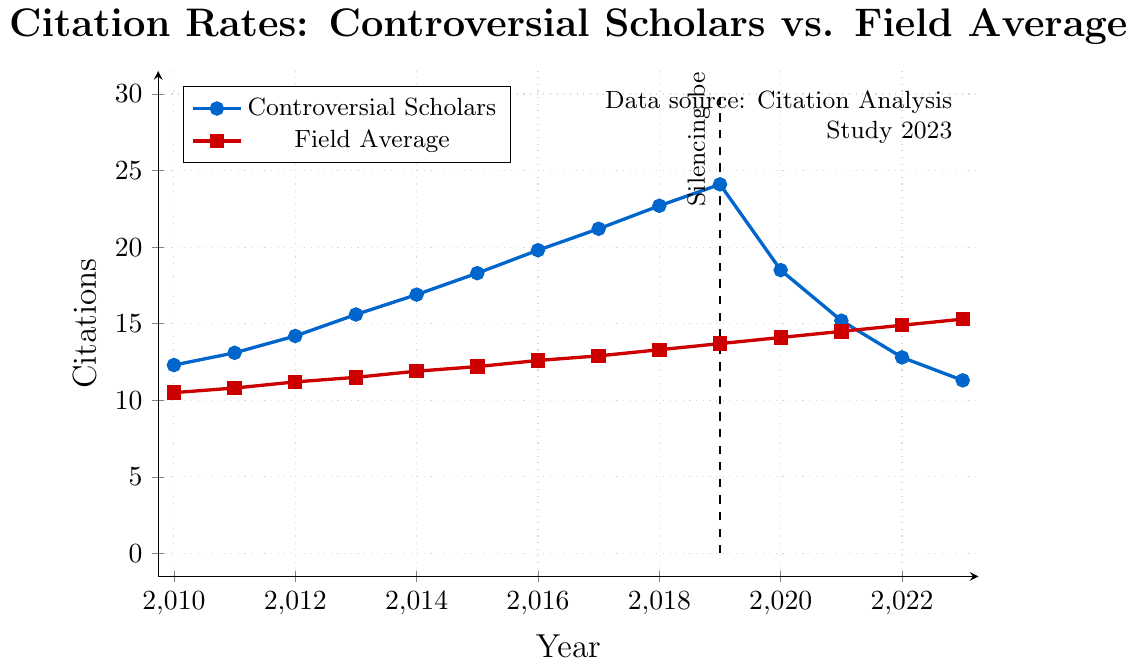what trend do you observe in the citation rates of controversial scholars after 2019 compared to the field average? After 2019, the citation rates for controversial scholars show a clear downward trend, from 24.1 to 11.3 in 2023. However, the field average continues to rise steadily from 13.7 to 15.3 during the same period. Thus, the citation rates for controversial scholars fall below the field average post-2019.
Answer: Downward for controversial scholars, upward for field average What was the highest citation rate for controversial scholars before they were silenced? To identify the highest citation rate for controversial scholars before they were silenced, examine the trend up to 2019. The rates are: 12.3, 13.1, 14.2, 15.6, 16.9, 18.3, 19.8, 21.2, 22.7, 24.1. The highest value among these is 24.1 in 2019.
Answer: 24.1 Compare the citation rates of controversial scholars and the field average in 2023. In 2023, the citation rate for controversial scholars is 11.3, while the field average is 15.3. The citation rate for controversial scholars is lower than the field average by (15.3 - 11.3) = 4.0.
Answer: Controversial scholars: 11.3, Field average: 15.3 How much did the citation rate of controversial scholars change from 2019 to 2023? The citation rate for controversial scholars in 2019 was 24.1 and in 2023 it is 11.3. The change is calculated as 24.1 - 11.3 = 12.8. Thus, there was a decrease of 12.8 citations.
Answer: Decreased by 12.8 What year did controversial scholars' citation rates start declining, and how does this compare to the trend in the field average? The citation rates for controversial scholars start to decline after 2019, when the silencing begins, while the field average continues its upward trend. By comparing the values visually, the decline starts in 2020, and the difference widens in the subsequent years.
Answer: Decline starts in 2020 for controversial scholars, field average continues to increase What is the visual indication of the start of the silencing period in the plot? The plot has a dashed vertical line labelled "Silencing begins" at the year 2019, which visually indicates the start of the silencing period. This line helps to identify the point of change in the citation trends for controversial scholars.
Answer: Dashed vertical line labelled "Silencing begins" at 2019 